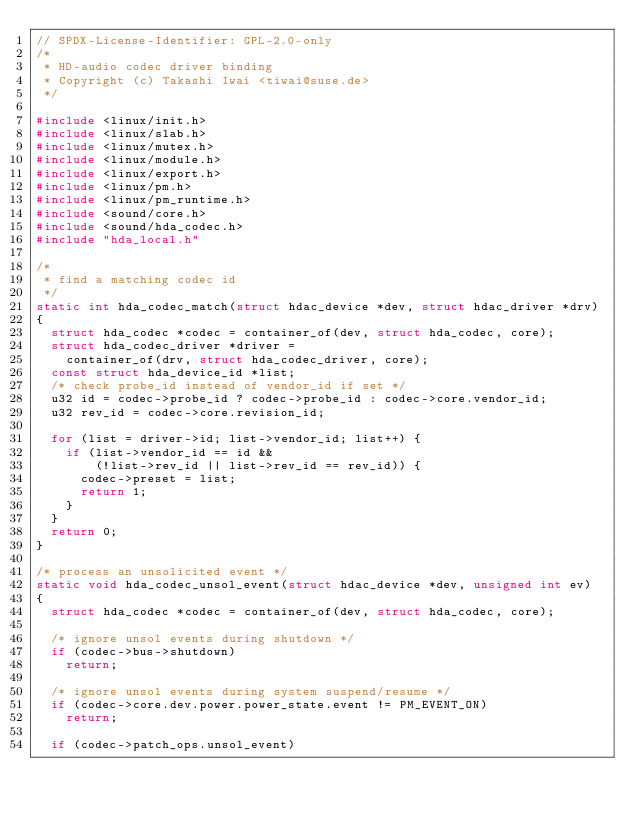<code> <loc_0><loc_0><loc_500><loc_500><_C_>// SPDX-License-Identifier: GPL-2.0-only
/*
 * HD-audio codec driver binding
 * Copyright (c) Takashi Iwai <tiwai@suse.de>
 */

#include <linux/init.h>
#include <linux/slab.h>
#include <linux/mutex.h>
#include <linux/module.h>
#include <linux/export.h>
#include <linux/pm.h>
#include <linux/pm_runtime.h>
#include <sound/core.h>
#include <sound/hda_codec.h>
#include "hda_local.h"

/*
 * find a matching codec id
 */
static int hda_codec_match(struct hdac_device *dev, struct hdac_driver *drv)
{
	struct hda_codec *codec = container_of(dev, struct hda_codec, core);
	struct hda_codec_driver *driver =
		container_of(drv, struct hda_codec_driver, core);
	const struct hda_device_id *list;
	/* check probe_id instead of vendor_id if set */
	u32 id = codec->probe_id ? codec->probe_id : codec->core.vendor_id;
	u32 rev_id = codec->core.revision_id;

	for (list = driver->id; list->vendor_id; list++) {
		if (list->vendor_id == id &&
		    (!list->rev_id || list->rev_id == rev_id)) {
			codec->preset = list;
			return 1;
		}
	}
	return 0;
}

/* process an unsolicited event */
static void hda_codec_unsol_event(struct hdac_device *dev, unsigned int ev)
{
	struct hda_codec *codec = container_of(dev, struct hda_codec, core);

	/* ignore unsol events during shutdown */
	if (codec->bus->shutdown)
		return;

	/* ignore unsol events during system suspend/resume */
	if (codec->core.dev.power.power_state.event != PM_EVENT_ON)
		return;

	if (codec->patch_ops.unsol_event)</code> 